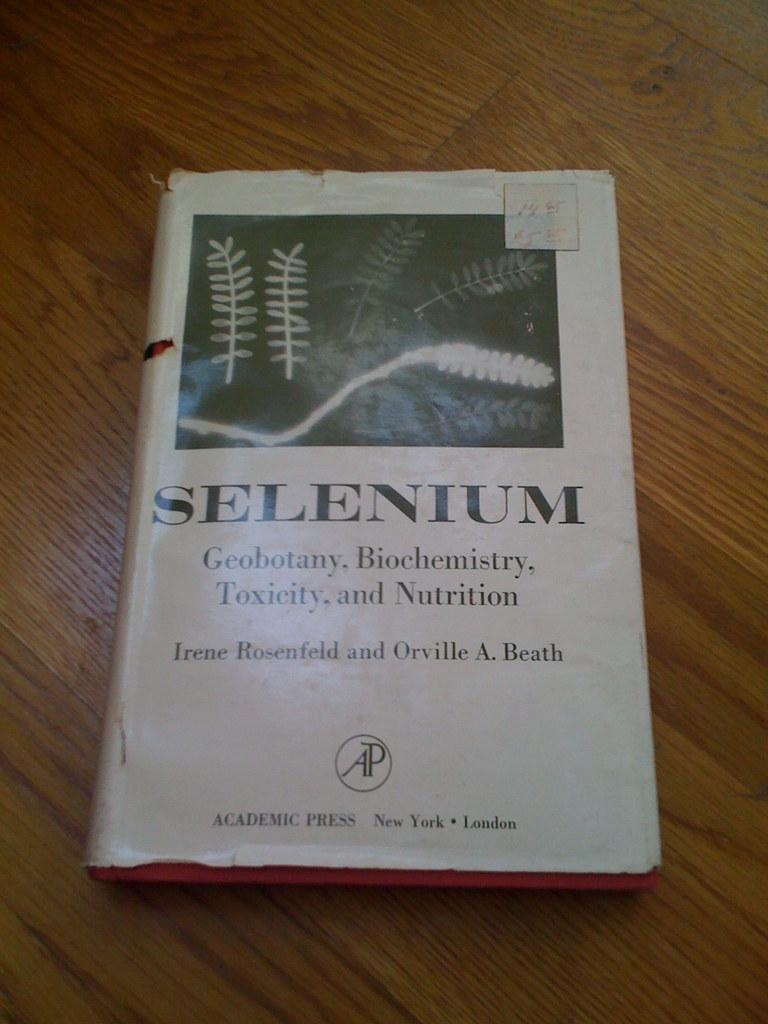What object is present in the image? There is a book in the image. Where is the book located? The book is on a wooden table. Can you see any seashore or train in the image? No, there is no seashore or train present in the image. What type of paste is being used to hold the pages of the book together? There is no mention of paste or any indication that the book's pages are being held together in the image. 